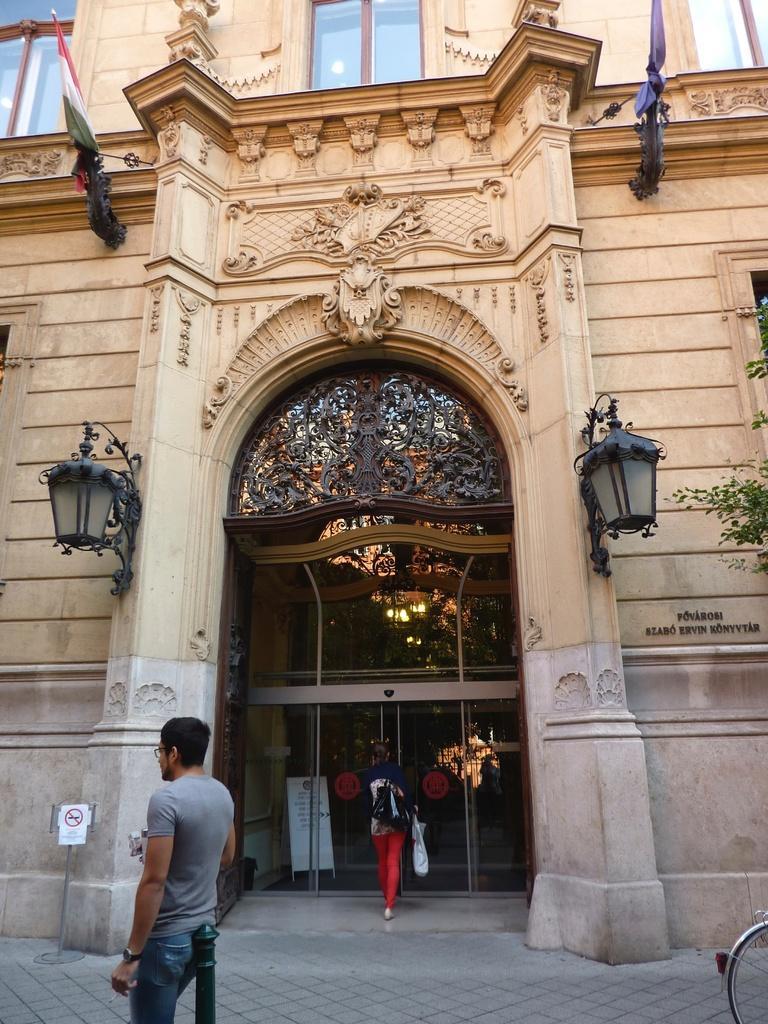In one or two sentences, can you explain what this image depicts? In this image we can see a building to which there are some lamps, flags, glass doors and there are two persons walking through the footpath. 